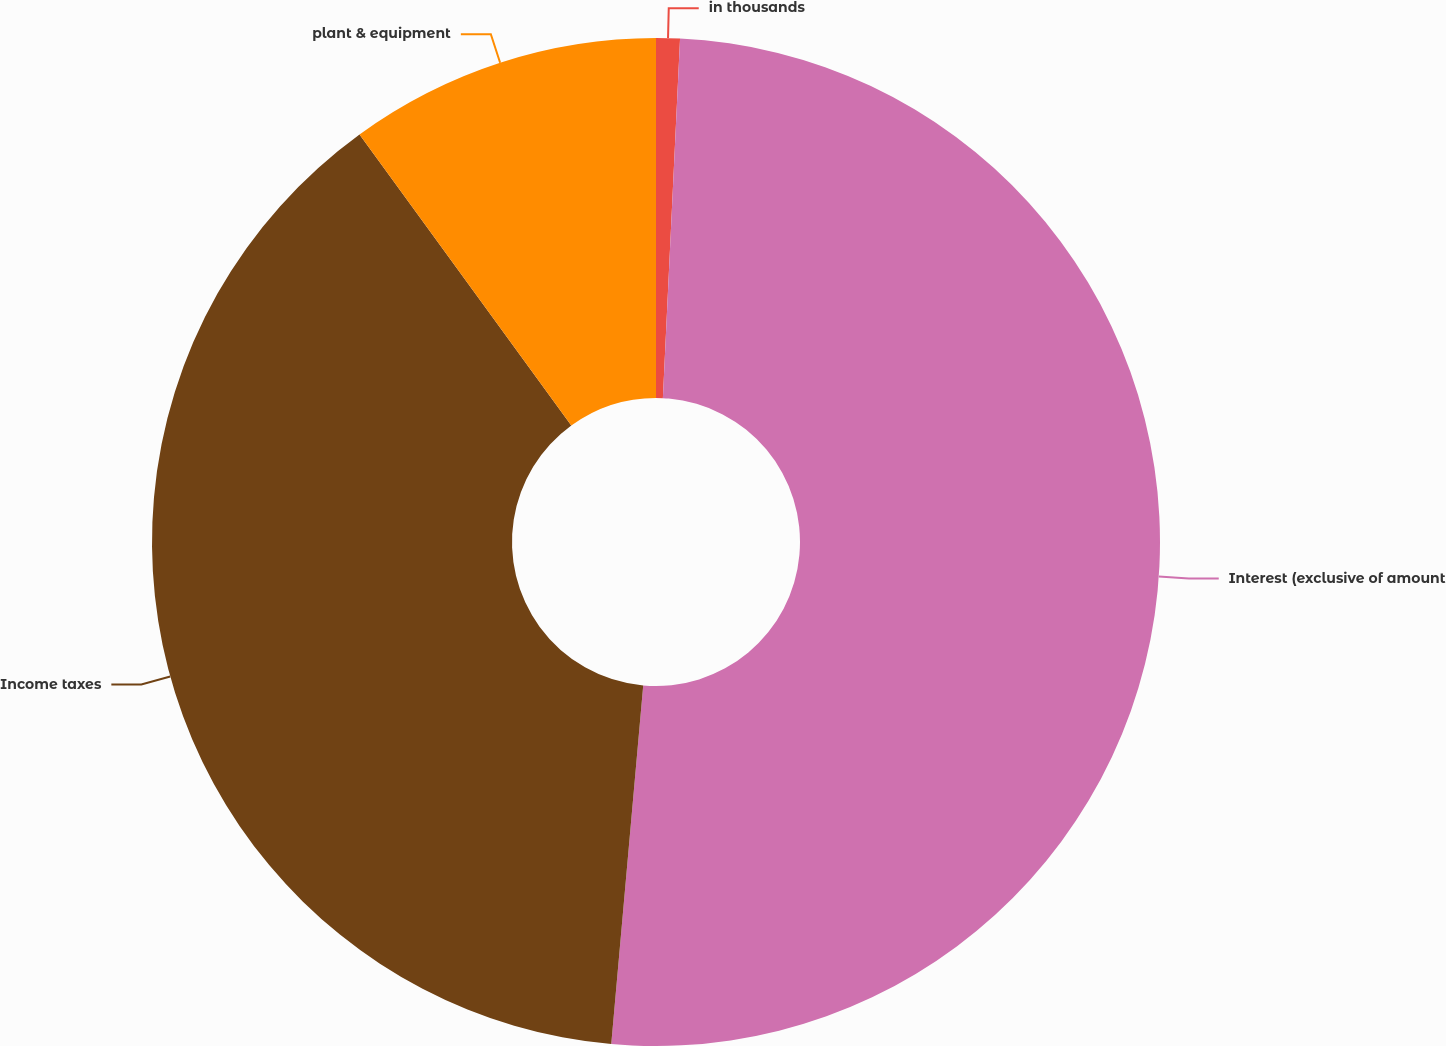Convert chart to OTSL. <chart><loc_0><loc_0><loc_500><loc_500><pie_chart><fcel>in thousands<fcel>Interest (exclusive of amount<fcel>Income taxes<fcel>plant & equipment<nl><fcel>0.76%<fcel>50.66%<fcel>38.58%<fcel>10.01%<nl></chart> 